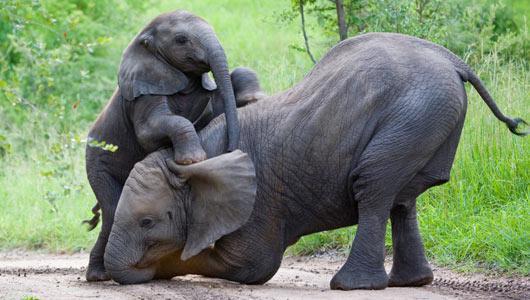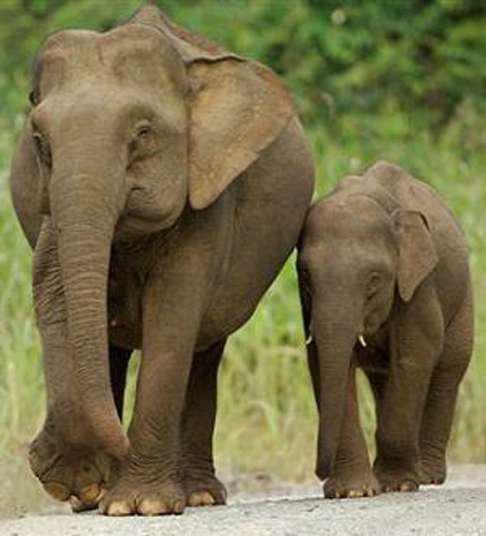The first image is the image on the left, the second image is the image on the right. For the images shown, is this caption "One of the images shows only one elephant." true? Answer yes or no. No. The first image is the image on the left, the second image is the image on the right. Examine the images to the left and right. Is the description "there are two elephants in the image on the right" accurate? Answer yes or no. Yes. The first image is the image on the left, the second image is the image on the right. Given the left and right images, does the statement "A mother and baby elephant are actively engaged together in a natural setting." hold true? Answer yes or no. Yes. 